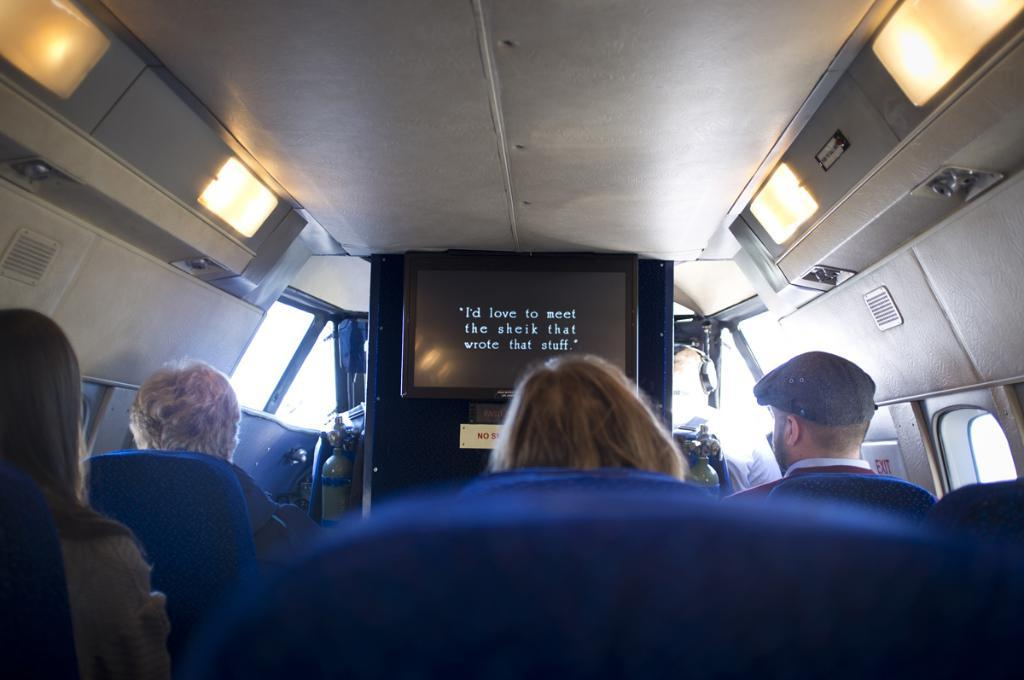What are the people in the image doing? The people in the image are sitting. What type of vehicle is depicted in the image? The image appears to depict a vehicle. What can be seen on the board in the image? There is a board with the letters "T. V." in the image. What is visible in the image that provides illumination? There are lights visible in the image. What safety device is present in the image? There is an extinguisher in the image. Can you see a pig playing with a leaf in the image? No, there is no pig or leaf present in the image. 